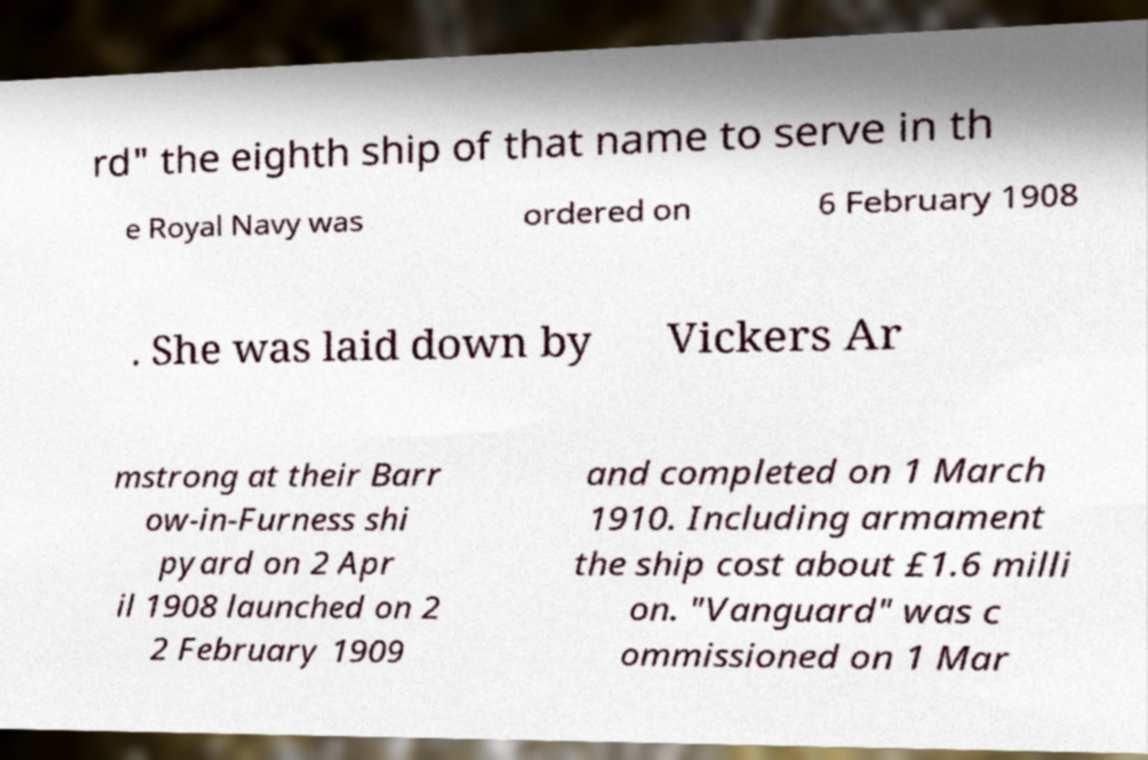There's text embedded in this image that I need extracted. Can you transcribe it verbatim? rd" the eighth ship of that name to serve in th e Royal Navy was ordered on 6 February 1908 . She was laid down by Vickers Ar mstrong at their Barr ow-in-Furness shi pyard on 2 Apr il 1908 launched on 2 2 February 1909 and completed on 1 March 1910. Including armament the ship cost about £1.6 milli on. "Vanguard" was c ommissioned on 1 Mar 